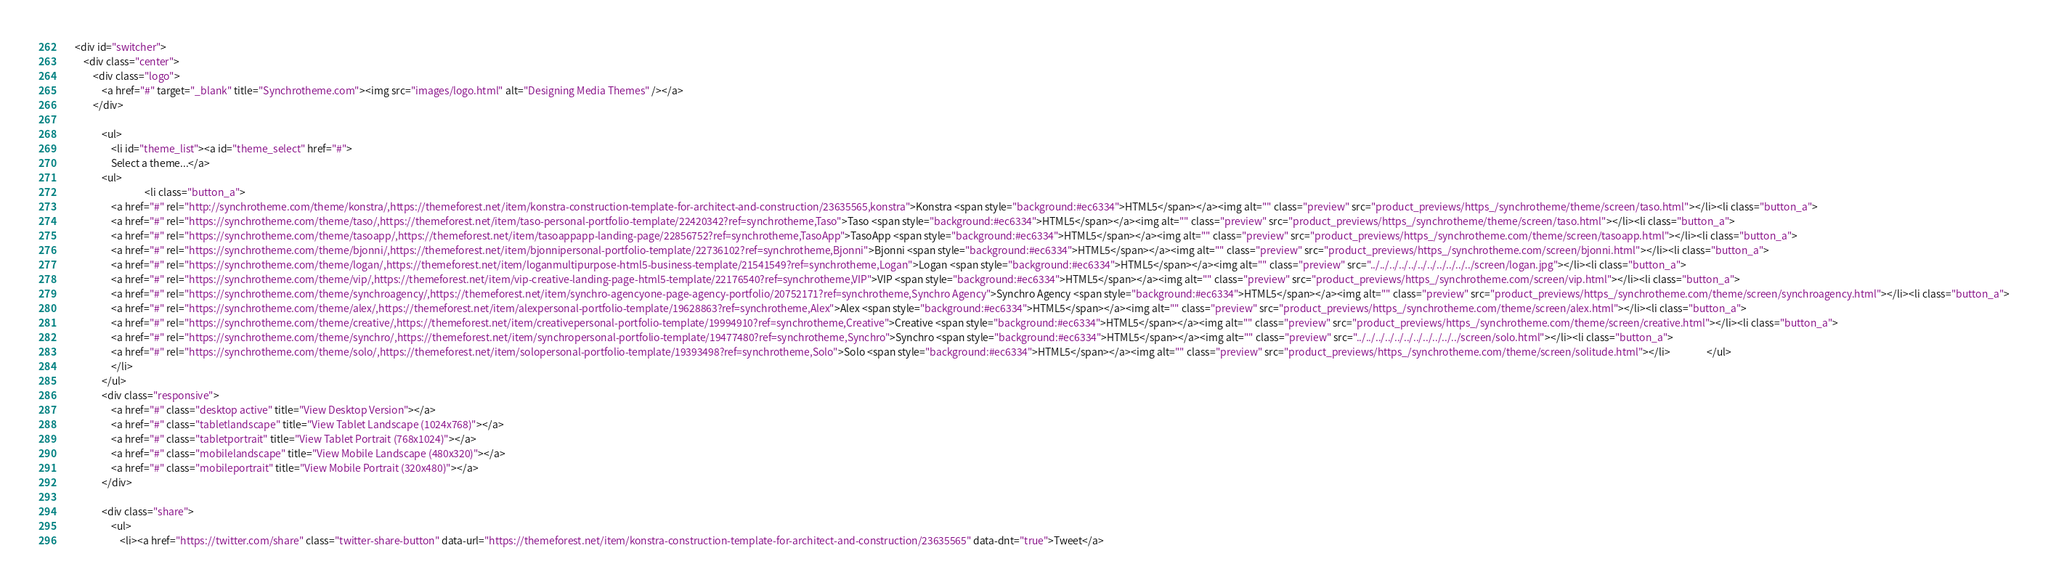<code> <loc_0><loc_0><loc_500><loc_500><_HTML_>    <div id="switcher">
		<div class="center">
            <div class="logo">
                <a href="#" target="_blank" title="Synchrotheme.com"><img src="images/logo.html" alt="Designing Media Themes" /></a>
            </div>
            				
                <ul>
                    <li id="theme_list"><a id="theme_select" href="#">
					Select a theme...</a>
				<ul>
				                   <li class="button_a">
					<a href="#" rel="http://synchrotheme.com/theme/konstra/,https://themeforest.net/item/konstra-construction-template-for-architect-and-construction/23635565,konstra">Konstra <span style="background:#ec6334">HTML5</span></a><img alt="" class="preview" src="product_previews/https_/synchrotheme/theme/screen/taso.html"></li><li class="button_a">
					<a href="#" rel="https://synchrotheme.com/theme/taso/,https://themeforest.net/item/taso-personal-portfolio-template/22420342?ref=synchrotheme,Taso">Taso <span style="background:#ec6334">HTML5</span></a><img alt="" class="preview" src="product_previews/https_/synchrotheme/theme/screen/taso.html"></li><li class="button_a">
					<a href="#" rel="https://synchrotheme.com/theme/tasoapp/,https://themeforest.net/item/tasoappapp-landing-page/22856752?ref=synchrotheme,TasoApp">TasoApp <span style="background:#ec6334">HTML5</span></a><img alt="" class="preview" src="product_previews/https_/synchrotheme.com/theme/screen/tasoapp.html"></li><li class="button_a">
					<a href="#" rel="https://synchrotheme.com/theme/bjonni/,https://themeforest.net/item/bjonnipersonal-portfolio-template/22736102?ref=synchrotheme,Bjonni">Bjonni <span style="background:#ec6334">HTML5</span></a><img alt="" class="preview" src="product_previews/https_/synchrotheme.com/screen/bjonni.html"></li><li class="button_a">
					<a href="#" rel="https://synchrotheme.com/theme/logan/,https://themeforest.net/item/loganmultipurpose-html5-business-template/21541549?ref=synchrotheme,Logan">Logan <span style="background:#ec6334">HTML5</span></a><img alt="" class="preview" src="../../../../../../../../../../../screen/logan.jpg"></li><li class="button_a">
					<a href="#" rel="https://synchrotheme.com/theme/vip/,https://themeforest.net/item/vip-creative-landing-page-html5-template/22176540?ref=synchrotheme,VIP">VIP <span style="background:#ec6334">HTML5</span></a><img alt="" class="preview" src="product_previews/https_/synchrotheme.com/screen/vip.html"></li><li class="button_a">
					<a href="#" rel="https://synchrotheme.com/theme/synchroagency/,https://themeforest.net/item/synchro-agencyone-page-agency-portfolio/20752171?ref=synchrotheme,Synchro Agency">Synchro Agency <span style="background:#ec6334">HTML5</span></a><img alt="" class="preview" src="product_previews/https_/synchrotheme.com/theme/screen/synchroagency.html"></li><li class="button_a">
					<a href="#" rel="https://synchrotheme.com/theme/alex/,https://themeforest.net/item/alexpersonal-portfolio-template/19628863?ref=synchrotheme,Alex">Alex <span style="background:#ec6334">HTML5</span></a><img alt="" class="preview" src="product_previews/https_/synchrotheme.com/theme/screen/alex.html"></li><li class="button_a">
					<a href="#" rel="https://synchrotheme.com/theme/creative/,https://themeforest.net/item/creativepersonal-portfolio-template/19994910?ref=synchrotheme,Creative">Creative <span style="background:#ec6334">HTML5</span></a><img alt="" class="preview" src="product_previews/https_/synchrotheme.com/theme/screen/creative.html"></li><li class="button_a">
					<a href="#" rel="https://synchrotheme.com/theme/synchro/,https://themeforest.net/item/synchropersonal-portfolio-template/19477480?ref=synchrotheme,Synchro">Synchro <span style="background:#ec6334">HTML5</span></a><img alt="" class="preview" src="../../../../../../../../../../../screen/solo.html"></li><li class="button_a">
					<a href="#" rel="https://synchrotheme.com/theme/solo/,https://themeforest.net/item/solopersonal-portfolio-template/19393498?ref=synchrotheme,Solo">Solo <span style="background:#ec6334">HTML5</span></a><img alt="" class="preview" src="product_previews/https_/synchrotheme.com/theme/screen/solitude.html"></li>                </ul>
                    </li>	
                </ul>
                <div class="responsive">
                    <a href="#" class="desktop active" title="View Desktop Version"></a> 
                    <a href="#" class="tabletlandscape" title="View Tablet Landscape (1024x768)"></a> 
                    <a href="#" class="tabletportrait" title="View Tablet Portrait (768x1024)"></a> 
                    <a href="#" class="mobilelandscape" title="View Mobile Landscape (480x320)"></a>
                    <a href="#" class="mobileportrait" title="View Mobile Portrait (320x480)"></a>
                </div>
                
                <div class="share">
                    <ul>
                        <li><a href="https://twitter.com/share" class="twitter-share-button" data-url="https://themeforest.net/item/konstra-construction-template-for-architect-and-construction/23635565" data-dnt="true">Tweet</a></code> 